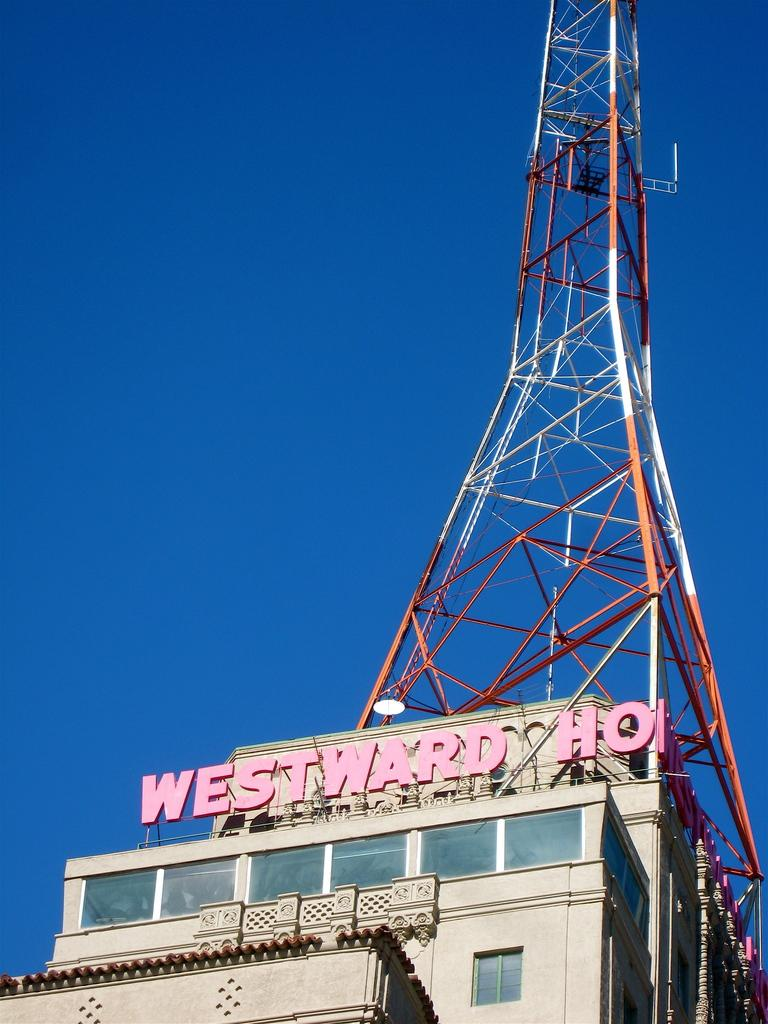What type of structure is in the picture? There is a building in the picture. What can be seen on the building? There is text on the building. What feature is on the top of the building? There is a tower on the top of the building. What is visible at the top of the image? The sky is visible at the top of the image. Can you see any rice being cooked on a trail in the image? There is no rice or trail present in the image; it features a building with text and a tower. 